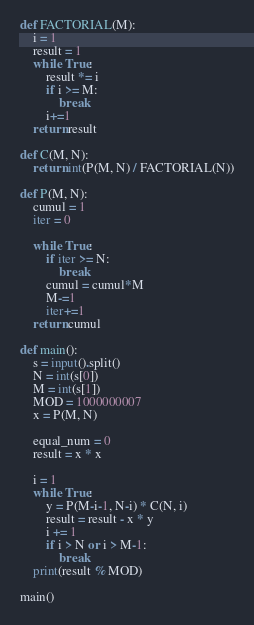Convert code to text. <code><loc_0><loc_0><loc_500><loc_500><_Python_>def FACTORIAL(M):
    i = 1
    result = 1
    while True:
        result *= i
        if i >= M:
            break
        i+=1
    return result

def C(M, N):
    return int(P(M, N) / FACTORIAL(N))

def P(M, N):
    cumul = 1
    iter = 0

    while True:
        if iter >= N:
            break
        cumul = cumul*M
        M-=1
        iter+=1
    return cumul

def main():
    s = input().split()
    N = int(s[0])
    M = int(s[1])
    MOD = 1000000007
    x = P(M, N)

    equal_num = 0
    result = x * x

    i = 1
    while True:
        y = P(M-i-1, N-i) * C(N, i)
        result = result - x * y
        i += 1
        if i > N or i > M-1:
            break
    print(result % MOD)

main()
</code> 